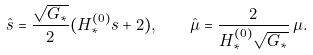<formula> <loc_0><loc_0><loc_500><loc_500>\hat { s } = \frac { \sqrt { G _ { * } } } 2 ( H ^ { ( 0 ) } _ { * } s + 2 ) , \quad \hat { \mu } = \frac { 2 } { H ^ { ( 0 ) } _ { * } \sqrt { G _ { * } } } \, \mu .</formula> 